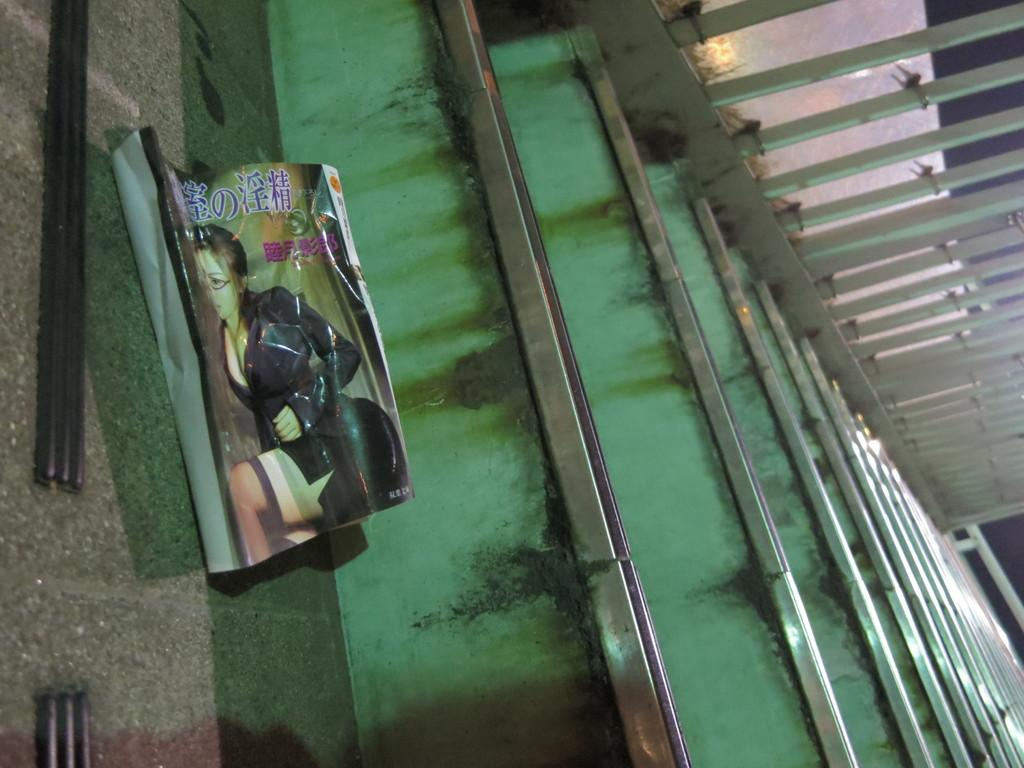What is covering the stairs in the image? There is a cover on the stairs in the image. What can be seen on the right side of the stairs in the image? There is a railing on the right side of the stairs in the image. Can you describe the texture of the owl's feathers in the image? There is no owl present in the image, so we cannot describe the texture of its feathers. What is the owl saying with its mouth in the image? There is no owl present in the image, so we cannot determine what it might be saying with its mouth. 